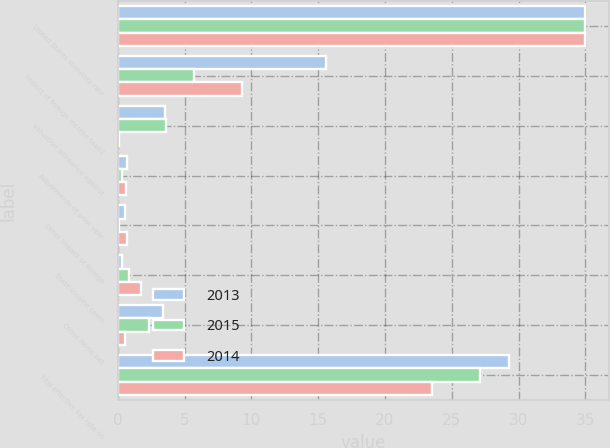Convert chart to OTSL. <chart><loc_0><loc_0><loc_500><loc_500><stacked_bar_chart><ecel><fcel>United States statutory rate<fcel>Impact of foreign income taxed<fcel>Valuation allowance against<fcel>Adjustments of prior year<fcel>Other impact of foreign<fcel>State income taxes<fcel>Other items net<fcel>Total effective tax rate on<nl><fcel>2013<fcel>35<fcel>15.6<fcel>3.5<fcel>0.7<fcel>0.5<fcel>0.3<fcel>3.4<fcel>29.3<nl><fcel>2015<fcel>35<fcel>5.7<fcel>3.6<fcel>0.3<fcel>0.1<fcel>0.8<fcel>2.3<fcel>27.1<nl><fcel>2014<fcel>35<fcel>9.3<fcel>0.1<fcel>0.6<fcel>0.7<fcel>1.7<fcel>0.5<fcel>23.5<nl></chart> 